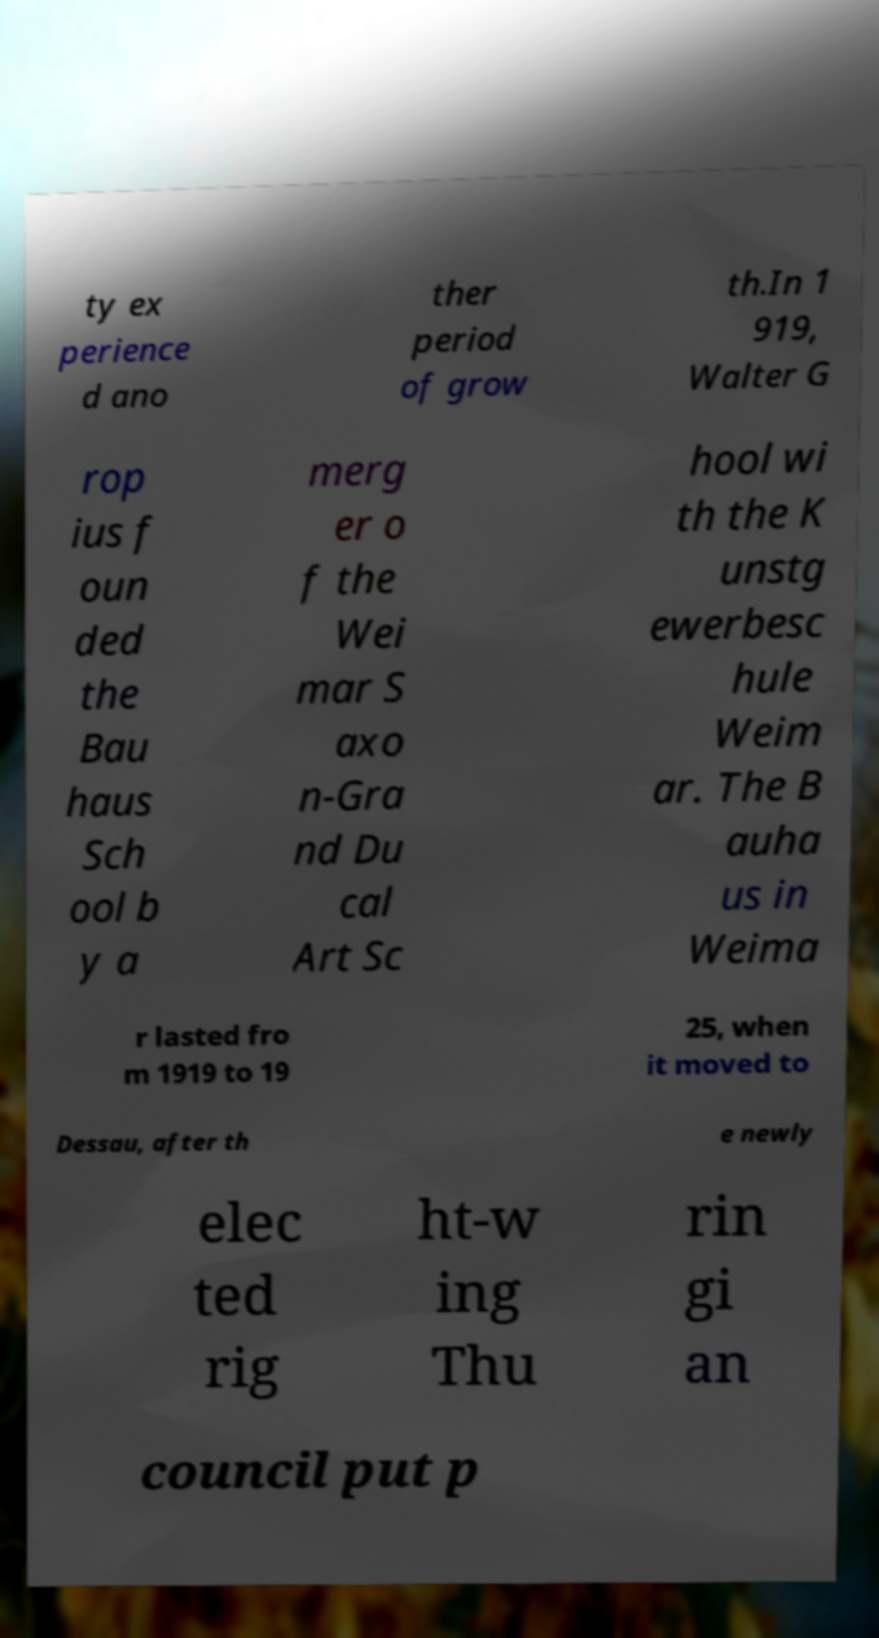Can you accurately transcribe the text from the provided image for me? ty ex perience d ano ther period of grow th.In 1 919, Walter G rop ius f oun ded the Bau haus Sch ool b y a merg er o f the Wei mar S axo n-Gra nd Du cal Art Sc hool wi th the K unstg ewerbesc hule Weim ar. The B auha us in Weima r lasted fro m 1919 to 19 25, when it moved to Dessau, after th e newly elec ted rig ht-w ing Thu rin gi an council put p 